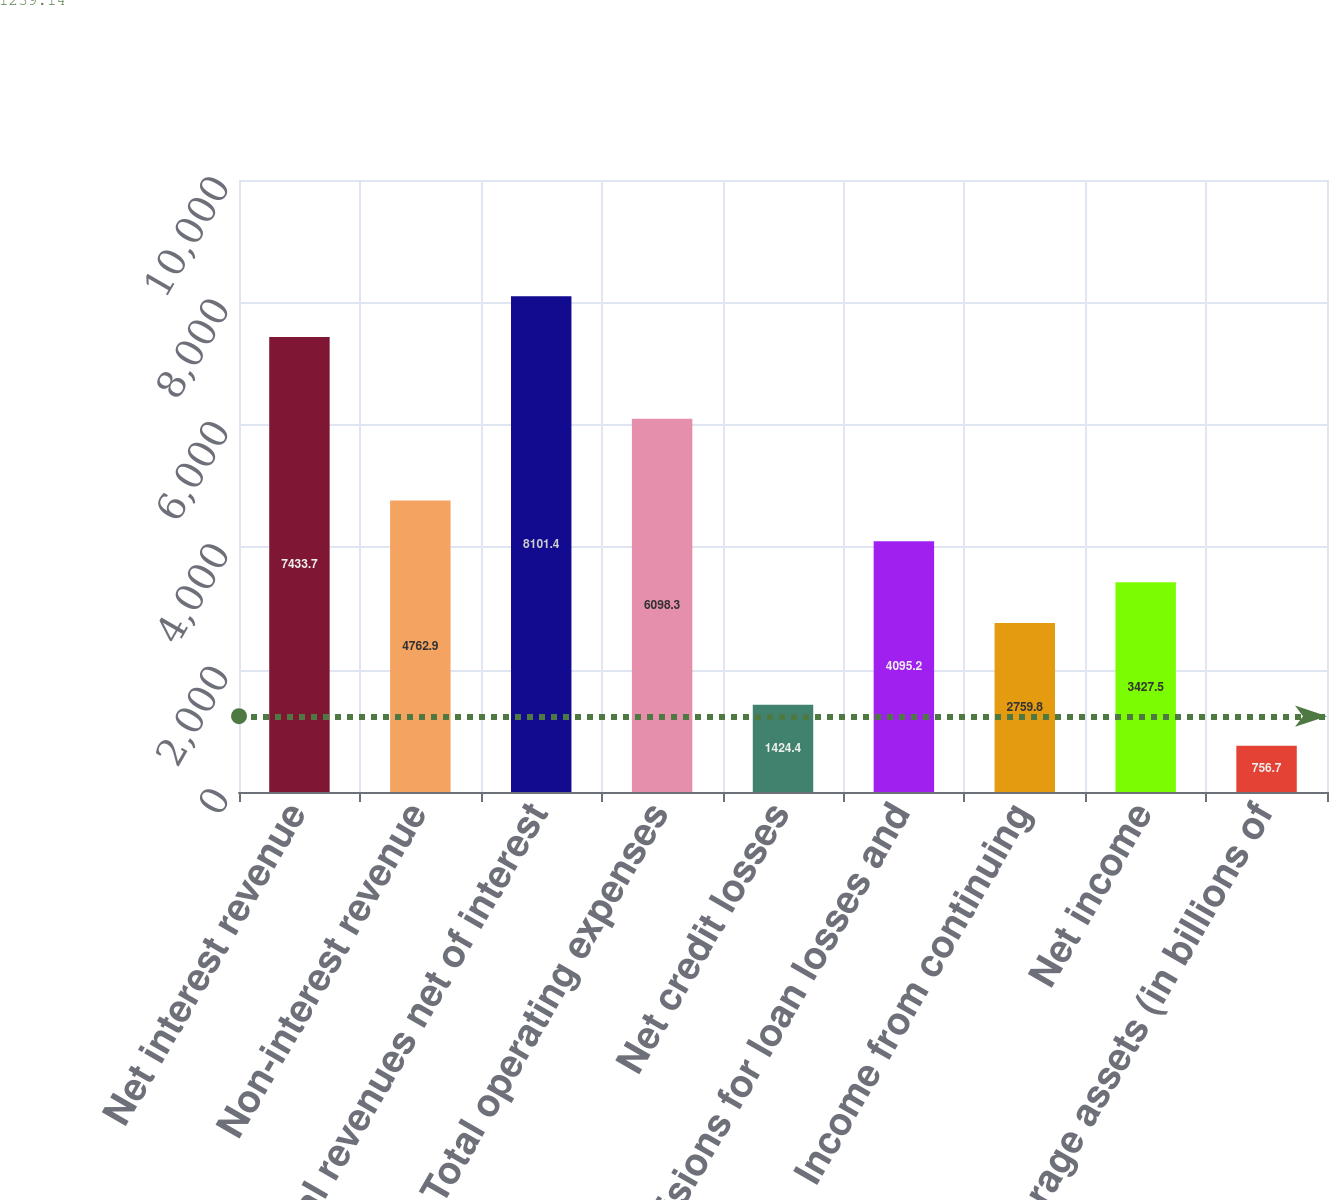<chart> <loc_0><loc_0><loc_500><loc_500><bar_chart><fcel>Net interest revenue<fcel>Non-interest revenue<fcel>Total revenues net of interest<fcel>Total operating expenses<fcel>Net credit losses<fcel>Provisions for loan losses and<fcel>Income from continuing<fcel>Net income<fcel>Average assets (in billions of<nl><fcel>7433.7<fcel>4762.9<fcel>8101.4<fcel>6098.3<fcel>1424.4<fcel>4095.2<fcel>2759.8<fcel>3427.5<fcel>756.7<nl></chart> 